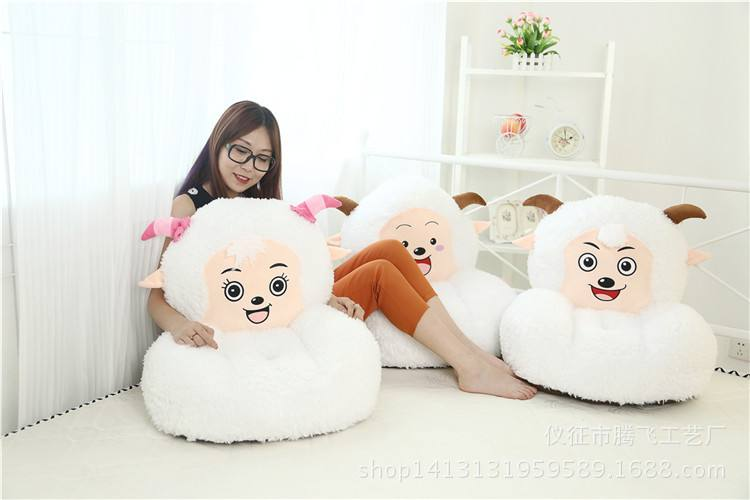Describe the style and mood of the furniture items shown in the image. The furniture items in the image exhibit a fun and youthful style, primarily designed to evoke cheerfulness. The sheep-themed sofas, for example, have jovial facial expressions, and the sleek, modern shelving unit complements the light-hearted aesthetic with its minimalistic design. 